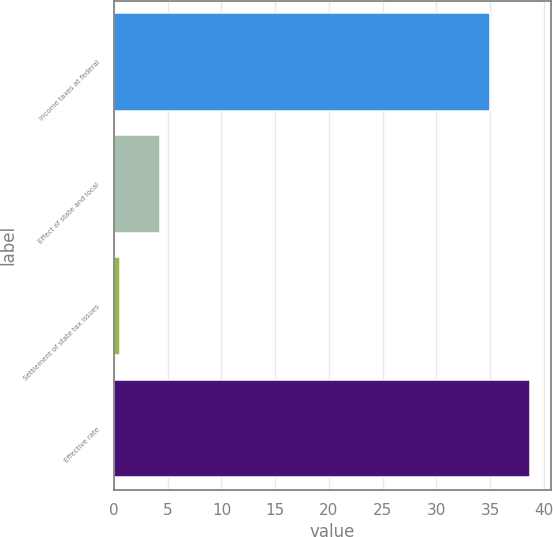<chart> <loc_0><loc_0><loc_500><loc_500><bar_chart><fcel>Income taxes at federal<fcel>Effect of state and local<fcel>Settlement of state tax issues<fcel>Effective rate<nl><fcel>35<fcel>4.24<fcel>0.52<fcel>38.72<nl></chart> 